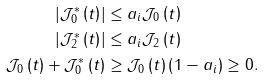<formula> <loc_0><loc_0><loc_500><loc_500>\left | \mathcal { J } _ { 0 } ^ { \ast } \left ( t \right ) \right | & \leq a _ { i } \mathcal { J } _ { 0 } \left ( t \right ) \\ \left | \mathcal { J } _ { 2 } ^ { \ast } \left ( t \right ) \right | & \leq a _ { i } \mathcal { J } _ { 2 } \left ( t \right ) \\ \mathcal { J } _ { 0 } \left ( t \right ) + \mathcal { J } _ { 0 } ^ { \ast } \left ( t \right ) & \geq \mathcal { J } _ { 0 } \left ( t \right ) \left ( 1 - a _ { i } \right ) \geq 0 .</formula> 